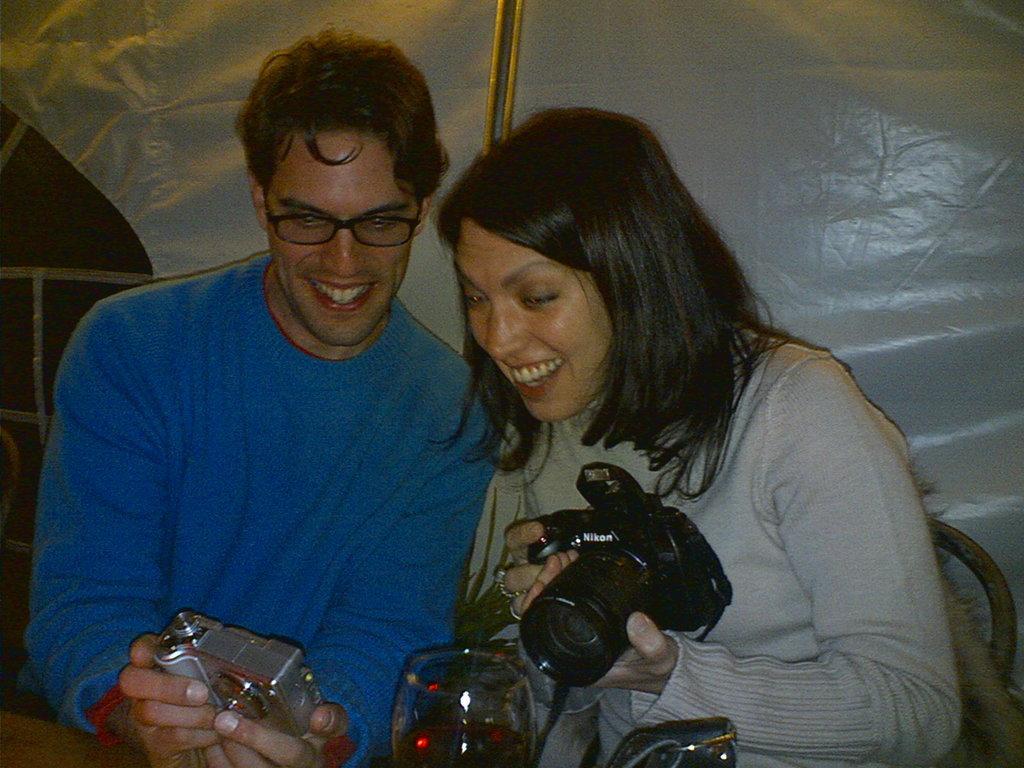In one or two sentences, can you explain what this image depicts? This 2 persons are sitting on a chair and holding a camera. This person wore blue t-shirt and this person wore ash t-shirt. In-front of them there is a glass. 